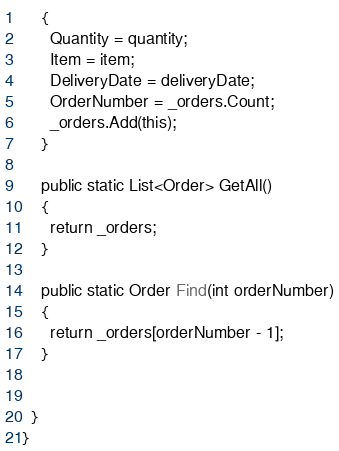Convert code to text. <code><loc_0><loc_0><loc_500><loc_500><_C#_>    {
      Quantity = quantity;
      Item = item;
      DeliveryDate = deliveryDate;
      OrderNumber = _orders.Count;
      _orders.Add(this);
    }

    public static List<Order> GetAll()
    {
      return _orders;
    }

    public static Order Find(int orderNumber)
    {
      return _orders[orderNumber - 1];
    }

    
  }
}</code> 